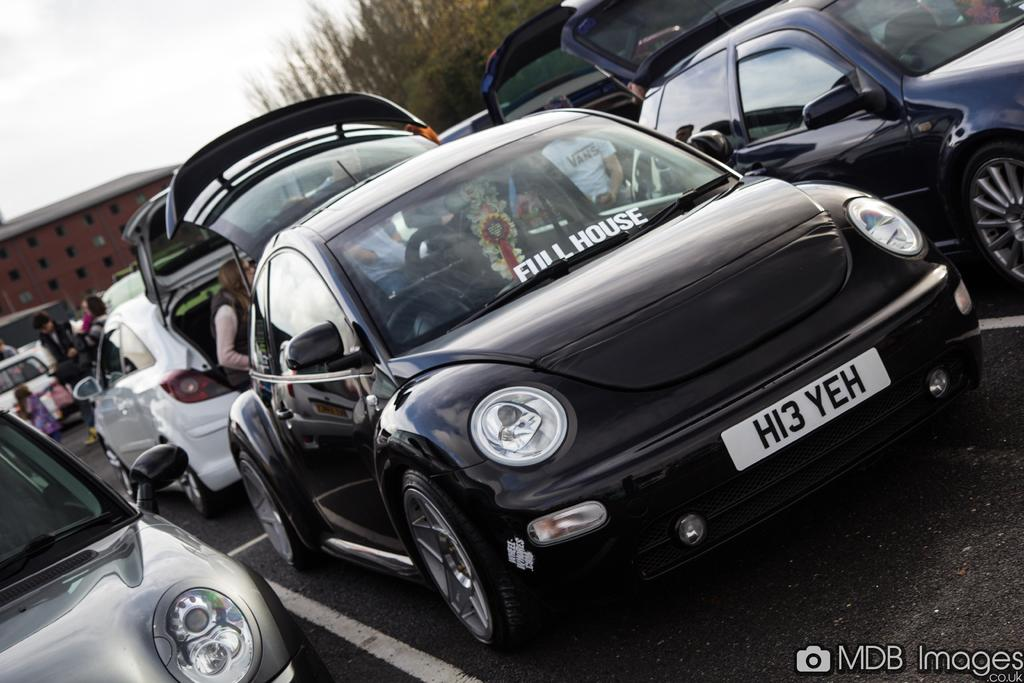What color are the cars in the image? The cars in the image are black. What else can be seen in the image besides the cars? There is a person standing, buildings, trees, and the sky is visible at the top of the image. What disease is the carpenter suffering from in the image? There is no carpenter or any mention of a disease in the image. 